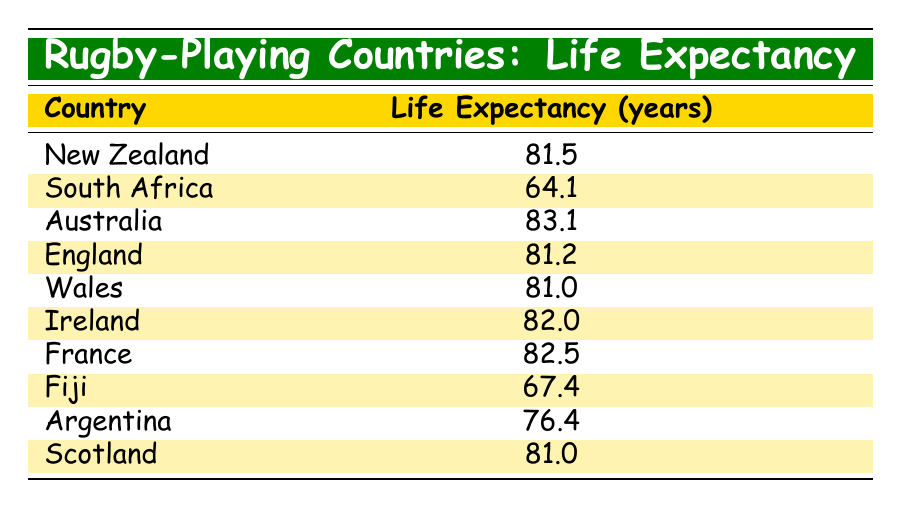What is the life expectancy of Australia? The life expectancy for Australia is directly stated in the table.
Answer: 83.1 Which country has the lowest life expectancy from the listed rugby-playing countries? The country with the lowest life expectancy can be found by comparing all the values in the life expectancy column. South Africa has the life expectancy of 64.1, which is lower than all others.
Answer: South Africa What is the average life expectancy of the rugby-playing countries in the table? To find the average, sum all the life expectancy values: (81.5 + 64.1 + 83.1 + 81.2 + 81.0 + 82.0 + 82.5 + 67.4 + 76.4 + 81.0) =  819.2. There are 10 countries, so the average is 819.2 / 10 = 81.92.
Answer: 81.92 Is the life expectancy of New Zealand greater than that of Fiji? By comparing the two values in the table, New Zealand has a life expectancy of 81.5, while Fiji has 67.4. Since 81.5 is greater than 67.4, the statement is true.
Answer: Yes How much longer can people expect to live in Australia compared to South Africa? The difference in life expectancy between Australia and South Africa can be calculated by subtracting South Africa's life expectancy from Australia's. That is 83.1 - 64.1 = 19 years.
Answer: 19 years Which countries have a life expectancy above 80 years? To find the countries above 80 years, one needs to review each country's life expectancy: New Zealand (81.5), Australia (83.1), England (81.2), Wales (81.0), Ireland (82.0), France (82.5), and Scotland (81.0) qualify.
Answer: New Zealand, Australia, England, Wales, Ireland, France, Scotland Is there only one country that has a life expectancy of exactly 81.0 years? By inspecting the table, both Wales and Scotland have a life expectancy of 81.0 years, which means the statement is false.
Answer: No How many countries have a life expectancy below 70 years? By checking the list, Fiji (67.4) and South Africa (64.1) are both below 70 years. Counting these gives a total of 2 countries.
Answer: 2 